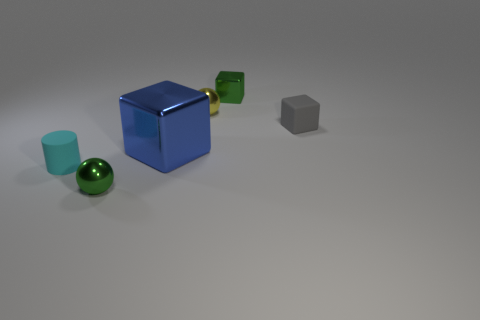What size is the green thing that is the same shape as the tiny gray object?
Make the answer very short. Small. There is a object that is the same color as the tiny metal cube; what size is it?
Your answer should be compact. Small. What number of things are either tiny metallic objects behind the large blue shiny object or small rubber things?
Ensure brevity in your answer.  4. Are there the same number of tiny yellow spheres on the right side of the tiny green cube and small cyan objects?
Provide a succinct answer. No. Is the matte cube the same size as the cyan cylinder?
Offer a terse response. Yes. The matte cube that is the same size as the cylinder is what color?
Offer a terse response. Gray. There is a cyan cylinder; is it the same size as the matte thing on the right side of the blue thing?
Keep it short and to the point. Yes. What number of spheres have the same color as the large object?
Keep it short and to the point. 0. What number of objects are either small rubber objects or large objects that are in front of the gray rubber block?
Make the answer very short. 3. Do the metallic cube that is behind the tiny gray rubber object and the rubber object behind the big metallic thing have the same size?
Provide a succinct answer. Yes. 